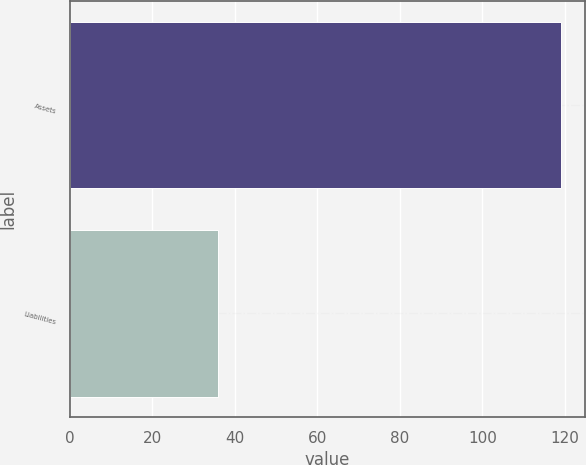Convert chart. <chart><loc_0><loc_0><loc_500><loc_500><bar_chart><fcel>Assets<fcel>Liabilities<nl><fcel>119<fcel>36<nl></chart> 